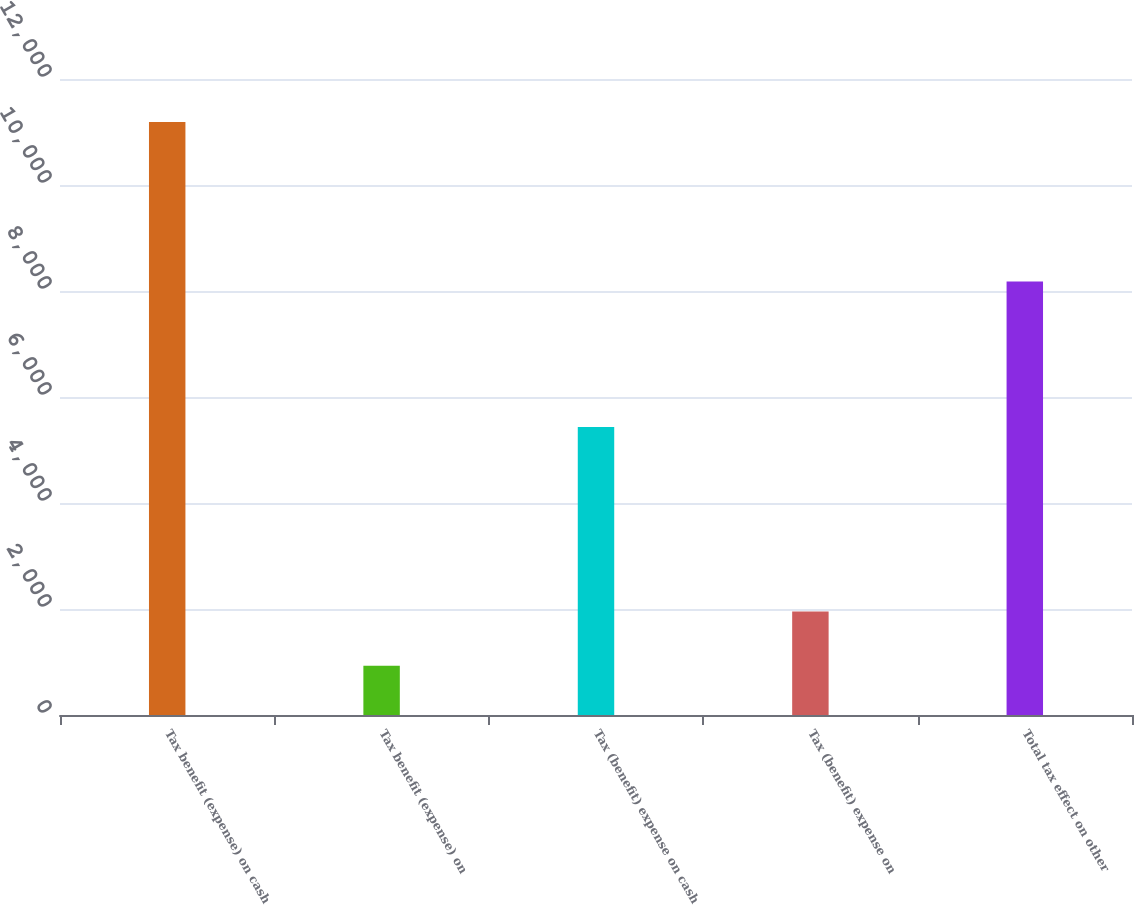Convert chart to OTSL. <chart><loc_0><loc_0><loc_500><loc_500><bar_chart><fcel>Tax benefit (expense) on cash<fcel>Tax benefit (expense) on<fcel>Tax (benefit) expense on cash<fcel>Tax (benefit) expense on<fcel>Total tax effect on other<nl><fcel>11190<fcel>928<fcel>5435<fcel>1954.2<fcel>8180<nl></chart> 